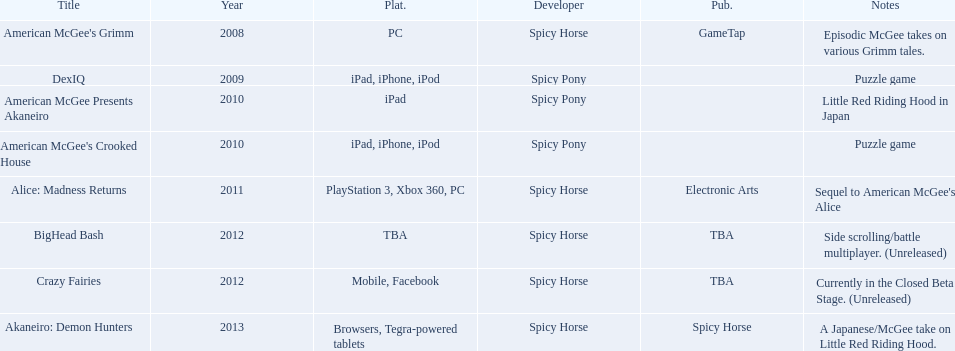Could you parse the entire table? {'header': ['Title', 'Year', 'Plat.', 'Developer', 'Pub.', 'Notes'], 'rows': [["American McGee's Grimm", '2008', 'PC', 'Spicy Horse', 'GameTap', 'Episodic McGee takes on various Grimm tales.'], ['DexIQ', '2009', 'iPad, iPhone, iPod', 'Spicy Pony', '', 'Puzzle game'], ['American McGee Presents Akaneiro', '2010', 'iPad', 'Spicy Pony', '', 'Little Red Riding Hood in Japan'], ["American McGee's Crooked House", '2010', 'iPad, iPhone, iPod', 'Spicy Pony', '', 'Puzzle game'], ['Alice: Madness Returns', '2011', 'PlayStation 3, Xbox 360, PC', 'Spicy Horse', 'Electronic Arts', "Sequel to American McGee's Alice"], ['BigHead Bash', '2012', 'TBA', 'Spicy Horse', 'TBA', 'Side scrolling/battle multiplayer. (Unreleased)'], ['Crazy Fairies', '2012', 'Mobile, Facebook', 'Spicy Horse', 'TBA', 'Currently in the Closed Beta Stage. (Unreleased)'], ['Akaneiro: Demon Hunters', '2013', 'Browsers, Tegra-powered tablets', 'Spicy Horse', 'Spicy Horse', 'A Japanese/McGee take on Little Red Riding Hood.']]} What are all the titles? American McGee's Grimm, DexIQ, American McGee Presents Akaneiro, American McGee's Crooked House, Alice: Madness Returns, BigHead Bash, Crazy Fairies, Akaneiro: Demon Hunters. What platforms were they available on? PC, iPad, iPhone, iPod, iPad, iPad, iPhone, iPod, PlayStation 3, Xbox 360, PC, TBA, Mobile, Facebook, Browsers, Tegra-powered tablets. And which were available only on the ipad? American McGee Presents Akaneiro. 